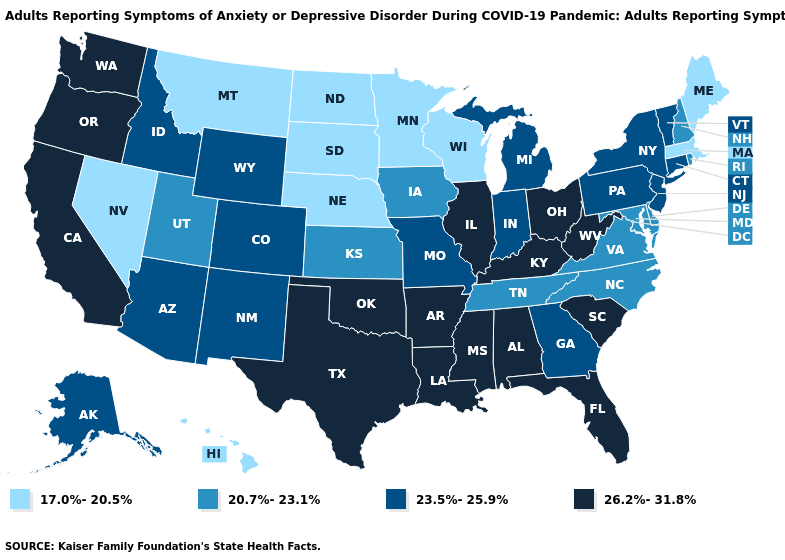Among the states that border Idaho , which have the highest value?
Be succinct. Oregon, Washington. What is the value of Kentucky?
Keep it brief. 26.2%-31.8%. Does Ohio have the highest value in the USA?
Write a very short answer. Yes. Which states have the highest value in the USA?
Be succinct. Alabama, Arkansas, California, Florida, Illinois, Kentucky, Louisiana, Mississippi, Ohio, Oklahoma, Oregon, South Carolina, Texas, Washington, West Virginia. Among the states that border Oregon , does Washington have the highest value?
Keep it brief. Yes. Does Wisconsin have the lowest value in the USA?
Write a very short answer. Yes. Does California have the highest value in the USA?
Be succinct. Yes. Which states have the lowest value in the USA?
Write a very short answer. Hawaii, Maine, Massachusetts, Minnesota, Montana, Nebraska, Nevada, North Dakota, South Dakota, Wisconsin. What is the highest value in the USA?
Short answer required. 26.2%-31.8%. Name the states that have a value in the range 17.0%-20.5%?
Keep it brief. Hawaii, Maine, Massachusetts, Minnesota, Montana, Nebraska, Nevada, North Dakota, South Dakota, Wisconsin. What is the highest value in the USA?
Quick response, please. 26.2%-31.8%. How many symbols are there in the legend?
Concise answer only. 4. Name the states that have a value in the range 23.5%-25.9%?
Answer briefly. Alaska, Arizona, Colorado, Connecticut, Georgia, Idaho, Indiana, Michigan, Missouri, New Jersey, New Mexico, New York, Pennsylvania, Vermont, Wyoming. Which states have the lowest value in the Northeast?
Be succinct. Maine, Massachusetts. Which states hav the highest value in the South?
Keep it brief. Alabama, Arkansas, Florida, Kentucky, Louisiana, Mississippi, Oklahoma, South Carolina, Texas, West Virginia. 